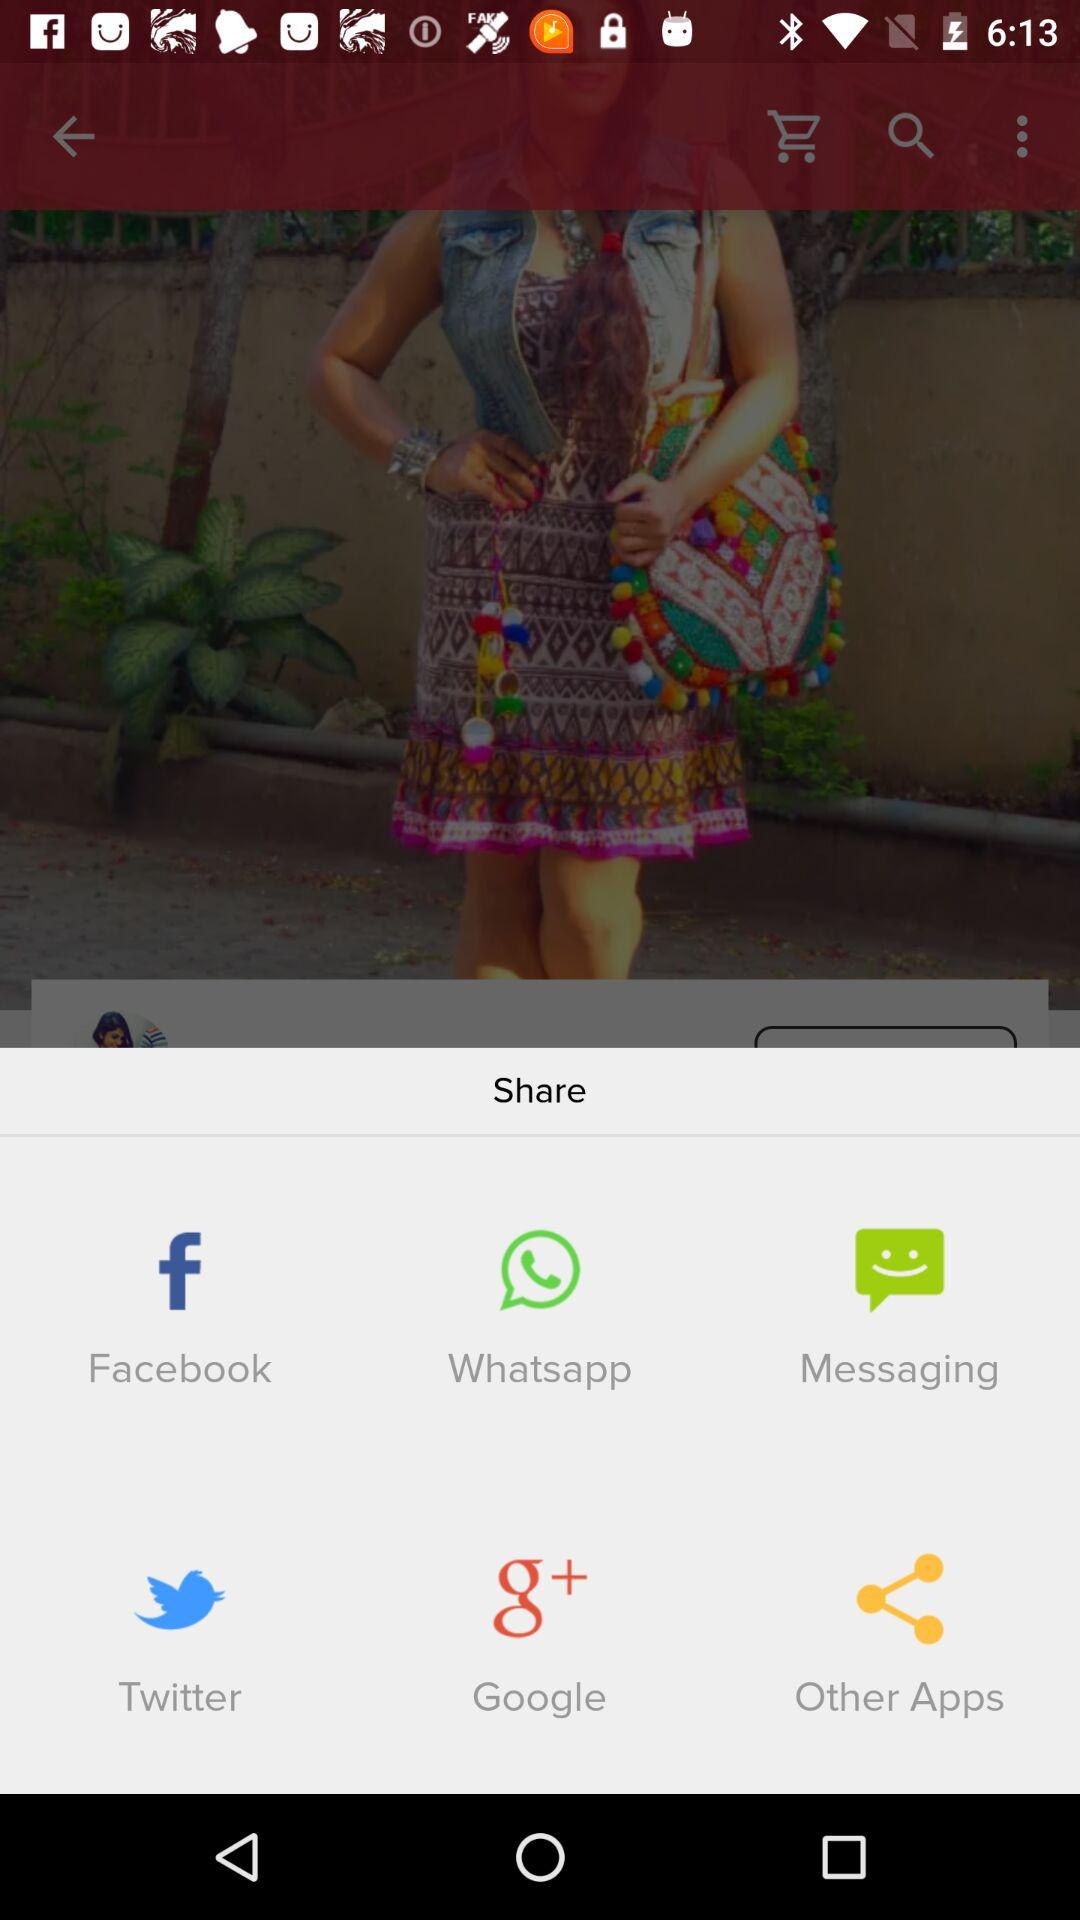What applications are used to share? The applications are "Facebook", "Whatsapp", "Messaging", "Twitter" and "Google". 